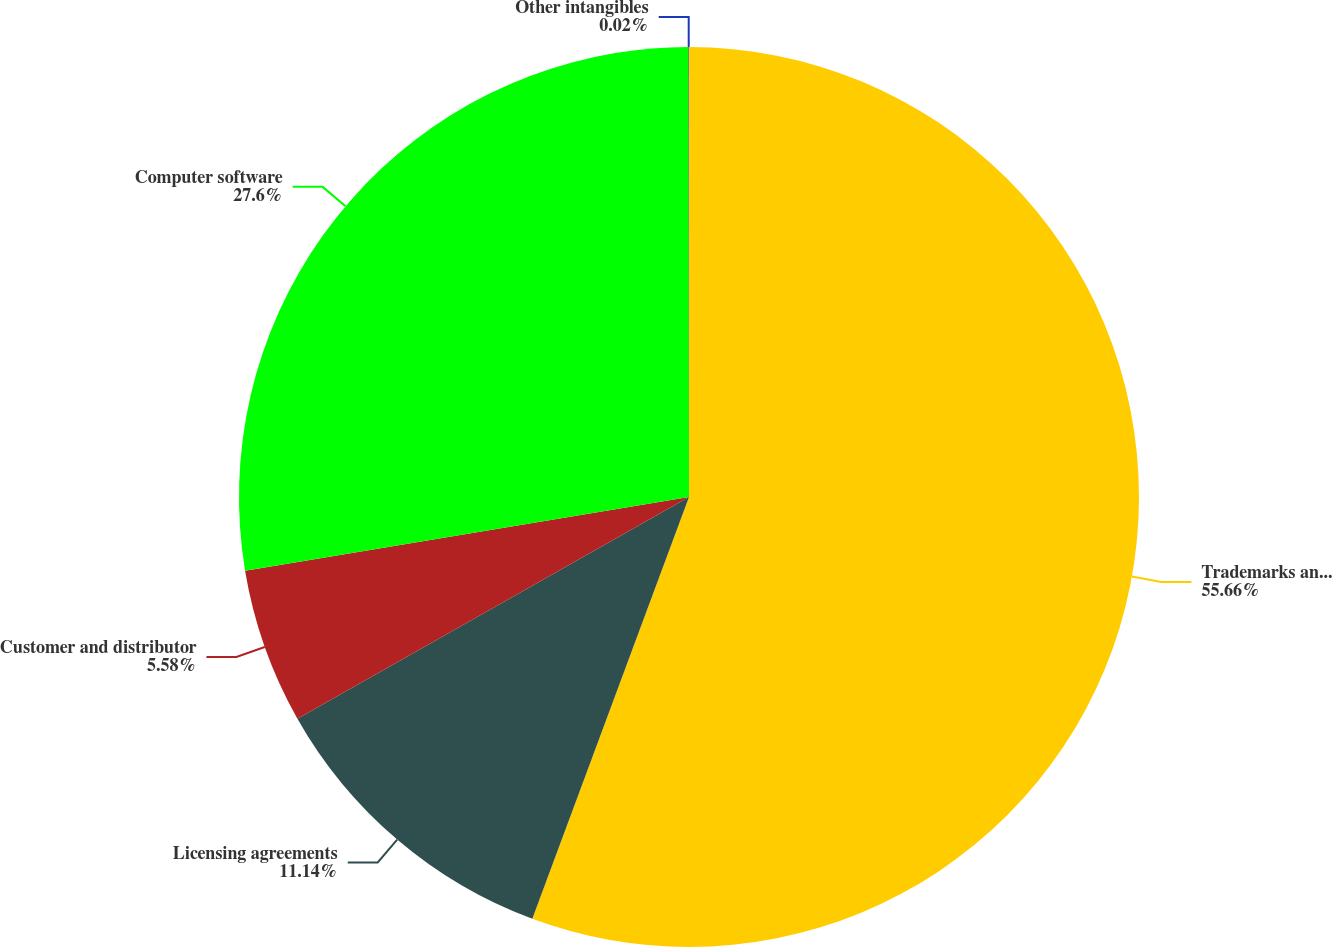Convert chart to OTSL. <chart><loc_0><loc_0><loc_500><loc_500><pie_chart><fcel>Trademarks and brand names<fcel>Licensing agreements<fcel>Customer and distributor<fcel>Computer software<fcel>Other intangibles<nl><fcel>55.66%<fcel>11.14%<fcel>5.58%<fcel>27.6%<fcel>0.02%<nl></chart> 